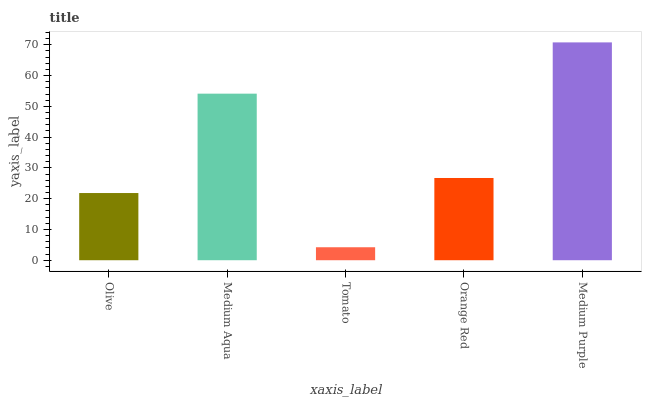Is Tomato the minimum?
Answer yes or no. Yes. Is Medium Purple the maximum?
Answer yes or no. Yes. Is Medium Aqua the minimum?
Answer yes or no. No. Is Medium Aqua the maximum?
Answer yes or no. No. Is Medium Aqua greater than Olive?
Answer yes or no. Yes. Is Olive less than Medium Aqua?
Answer yes or no. Yes. Is Olive greater than Medium Aqua?
Answer yes or no. No. Is Medium Aqua less than Olive?
Answer yes or no. No. Is Orange Red the high median?
Answer yes or no. Yes. Is Orange Red the low median?
Answer yes or no. Yes. Is Olive the high median?
Answer yes or no. No. Is Medium Purple the low median?
Answer yes or no. No. 